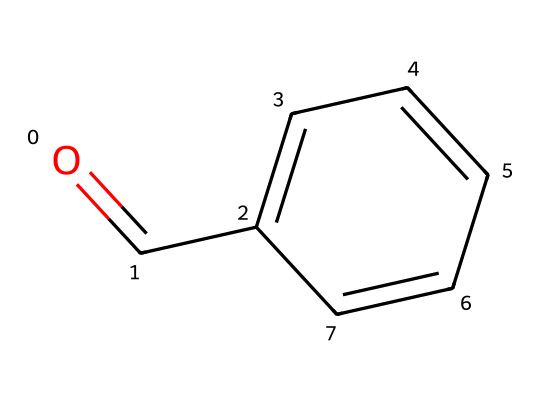What is the molecular formula of benzaldehyde? The molecular formula can be derived from the SMILES representation. Counting the carbon (C), hydrogen (H), and oxygen (O) atoms, there are 7 carbons, 6 hydrogens, and 1 oxygen. Therefore, the molecular formula is C7H6O.
Answer: C7H6O How many carbon atoms are present in this compound? From the structure given in the SMILES representation, there are 7 carbon atoms that can be counted directly.
Answer: 7 What type of functional group is present in benzaldehyde? Examining the structure, benzaldehyde contains a carbonyl group (C=O) attached to a benzene ring, making it an aromatic aldehyde. The functional group is the aldehyde group, which is characterized by the presence of a carbonyl group at the end of the carbon chain.
Answer: aldehyde What is the significance of the benzene ring in benzaldehyde? The benzene ring is important as it provides the aromatic properties of the compound, including its stability and the characteristic odors associated with aromatic compounds. The delocalized electrons in the benzene contribute to these properties.
Answer: aromatic properties What is the total number of double bonds in benzaldehyde? In the structural representation, there is one double bond in the carbonyl group (C=O) plus it has alternating double bonds between the carbon atoms in the benzene ring, totaling 4. Thus, there are 5 double bonds in total.
Answer: 5 What characteristic scent is associated with benzaldehyde? Benzaldehyde is commonly known for its almond-like scent which is a distinct characteristic that can be recognized in many essential oils and flavoring agents. This association is made due to the presence of the aromatic compound in its structure.
Answer: almond-like scent 